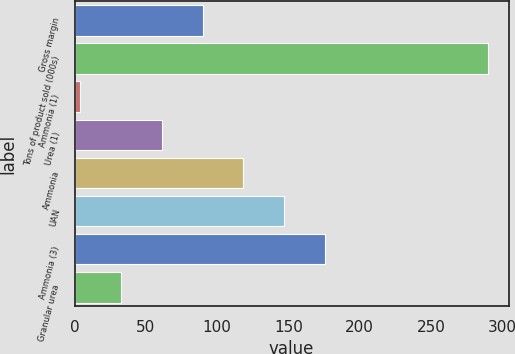Convert chart. <chart><loc_0><loc_0><loc_500><loc_500><bar_chart><fcel>Gross margin<fcel>Tons of product sold (000s)<fcel>Ammonia (1)<fcel>Urea (1)<fcel>Ammonia<fcel>UAN<fcel>Ammonia (3)<fcel>Granular urea<nl><fcel>89.8<fcel>290<fcel>4<fcel>61.2<fcel>118.4<fcel>147<fcel>175.6<fcel>32.6<nl></chart> 